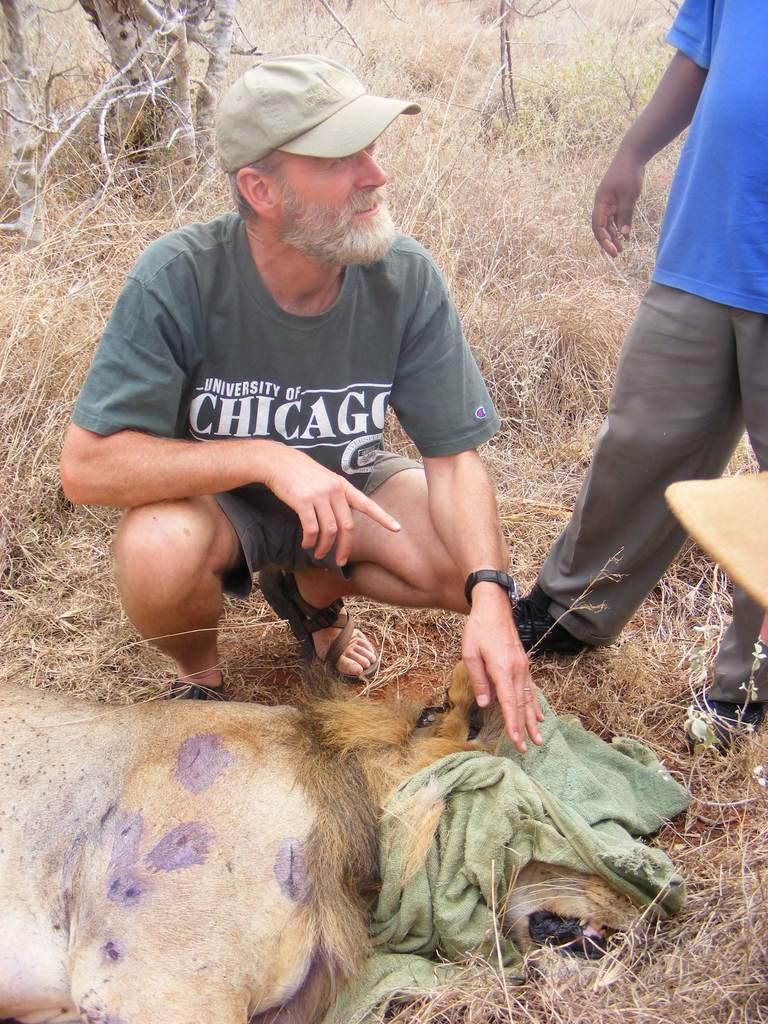Can you describe this image briefly? In the center of the image there is a person sitting at the lion. On the right side of the image we can see person and grass. In the background we can see trees and grass. 